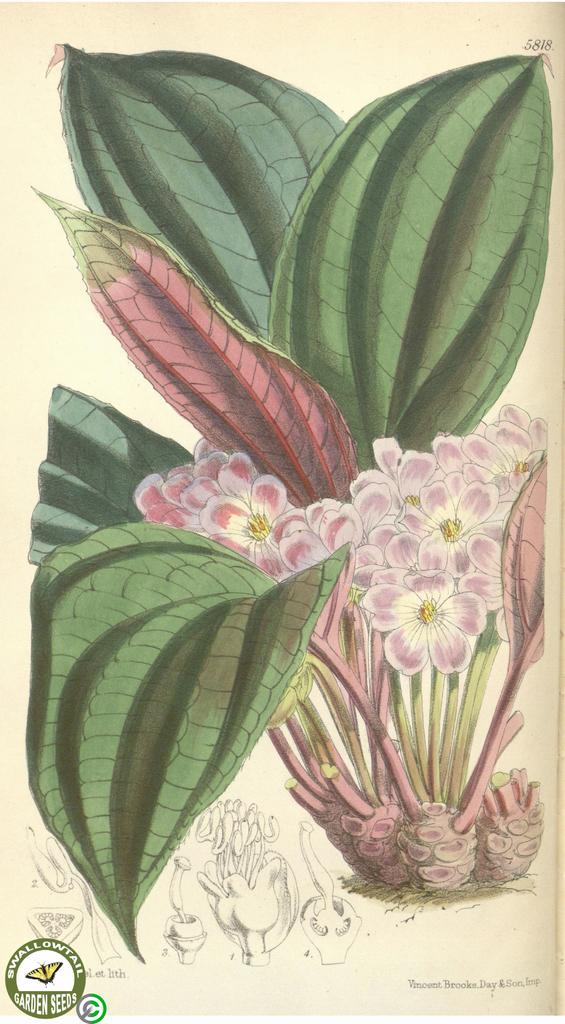What is the main subject of the painting in the image? The main subject of the painting in the image is a flower plant. Where is the painting located within the image? The painting is in the middle of the image. Is there any additional information or markings visible in the image? Yes, there is a watermark in the bottom left corner of the image. How many pies are displayed on the table in the image? There are no pies present in the image; it features a painting of a flower plant. What is the reason for the flower plant being painted in the image? The image does not provide any information about the reason for the flower plant being painted, so we cannot determine the reason from the image alone. 